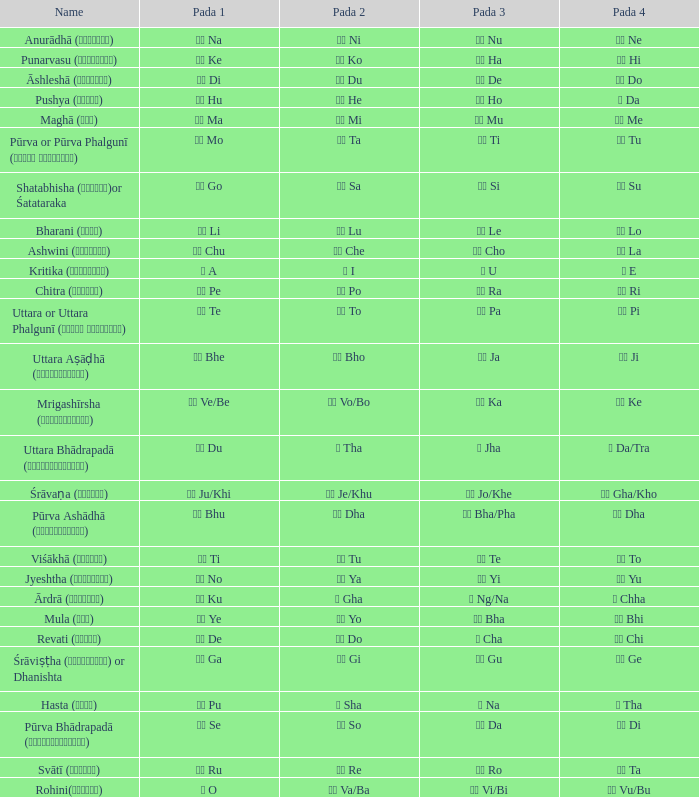Which Pada 3 has a Pada 1 of टे te? पा Pa. 